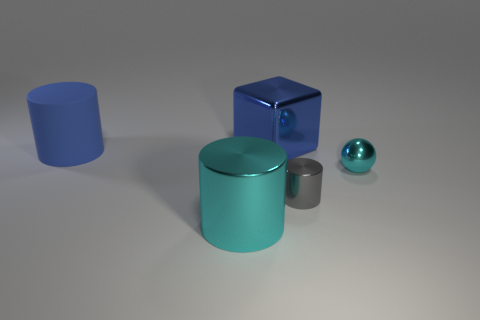What shape is the small cyan thing?
Offer a terse response. Sphere. There is a object behind the large cylinder that is behind the tiny cyan metal object; what size is it?
Your response must be concise. Large. Are there the same number of large cyan shiny cylinders that are left of the shiny cube and cylinders right of the small ball?
Your answer should be very brief. No. There is a object that is in front of the large matte cylinder and behind the small gray object; what material is it made of?
Provide a short and direct response. Metal. Is the size of the cyan metal cylinder the same as the cyan thing on the right side of the blue metallic thing?
Your response must be concise. No. What number of other things are the same color as the big block?
Ensure brevity in your answer.  1. Is the number of cyan objects that are right of the blue shiny block greater than the number of yellow shiny cylinders?
Provide a short and direct response. Yes. What color is the large cylinder that is to the left of the large metallic object in front of the large shiny thing that is behind the blue rubber cylinder?
Your answer should be very brief. Blue. Are the gray cylinder and the tiny cyan sphere made of the same material?
Your answer should be compact. Yes. Are there any gray objects of the same size as the gray shiny cylinder?
Ensure brevity in your answer.  No. 